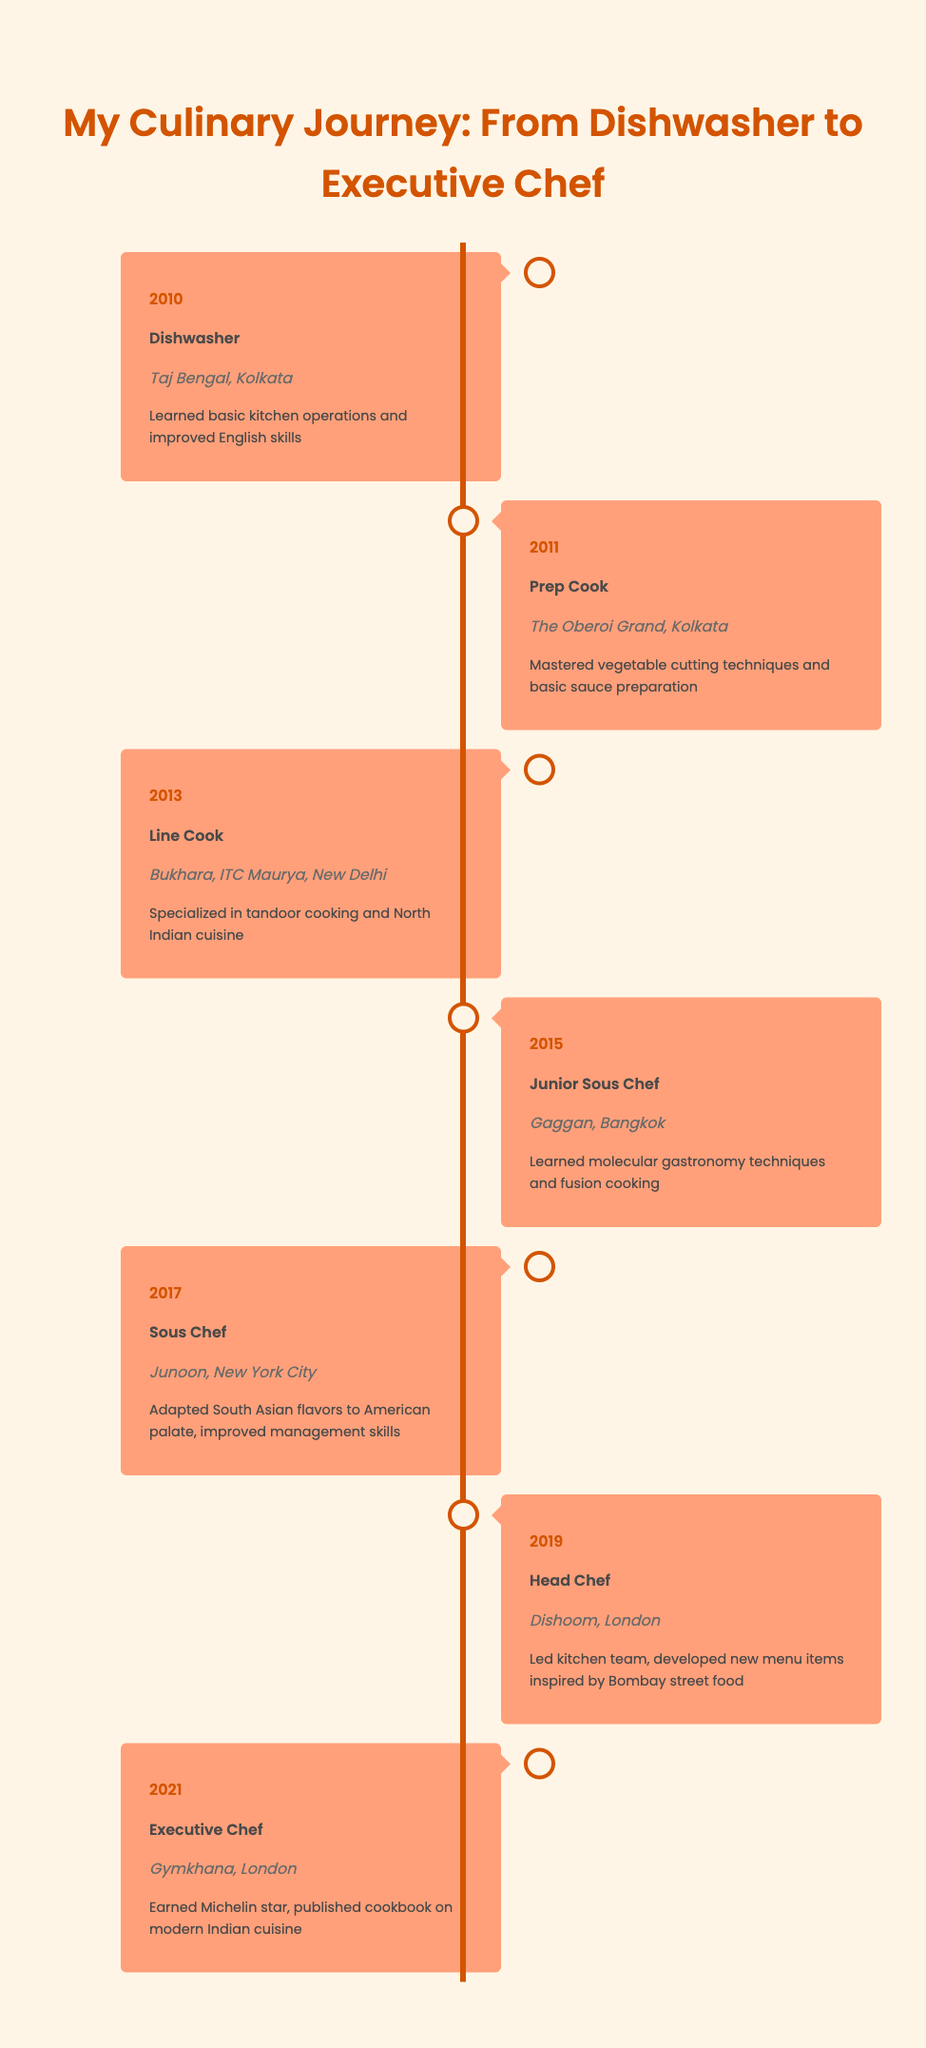What year did the chef become Head Chef? The table indicates that the chef became Head Chef in the year 2019, as noted in the row corresponding to that position.
Answer: 2019 What position did the chef hold at Gymkhana? According to the timeline, the chef held the position of Executive Chef at Gymkhana, which is stated in the entry for the year 2021.
Answer: Executive Chef How many years did the chef work before becoming a Sous Chef? The chef started as a Dishwasher in 2010 and became a Sous Chef in 2017. Thus, the difference is 2017 - 2010 = 7 years.
Answer: 7 years Did the chef earn a Michelin star? Yes, the chef earned a Michelin star while working as an Executive Chef at Gymkhana in 2021, according to the corresponding entry in the timeline.
Answer: Yes Which position was held the longest by the chef? The chef worked as a Sous Chef from 2017 to 2019, which is a span of 2 years, whereas no other position in the timeline is held for longer than that duration. Therefore, the answer is Sous Chef.
Answer: Sous Chef What is the average number of years the chef spent in each position? The chef held the following positions: Dishwasher (1 year), Prep Cook (1 year), Line Cook (2 years), Junior Sous Chef (2 years), Sous Chef (2 years), Head Chef (2 years), Executive Chef (2 years). Adding these durations gives a total of 12 years across 7 positions, thus the average is 12 / 7 = approximately 1.71 years.
Answer: 1.71 years What culinary skill did the chef learn at Gaggan? At Gaggan, the chef learned molecular gastronomy techniques and fusion cooking, as mentioned in the entry for that year.
Answer: Molecular gastronomy techniques and fusion cooking In which city did the chef work as a Junior Sous Chef? The timeline states that the chef worked as a Junior Sous Chef at Gaggan, which is located in Bangkok, as indicated in the respective entry.
Answer: Bangkok 